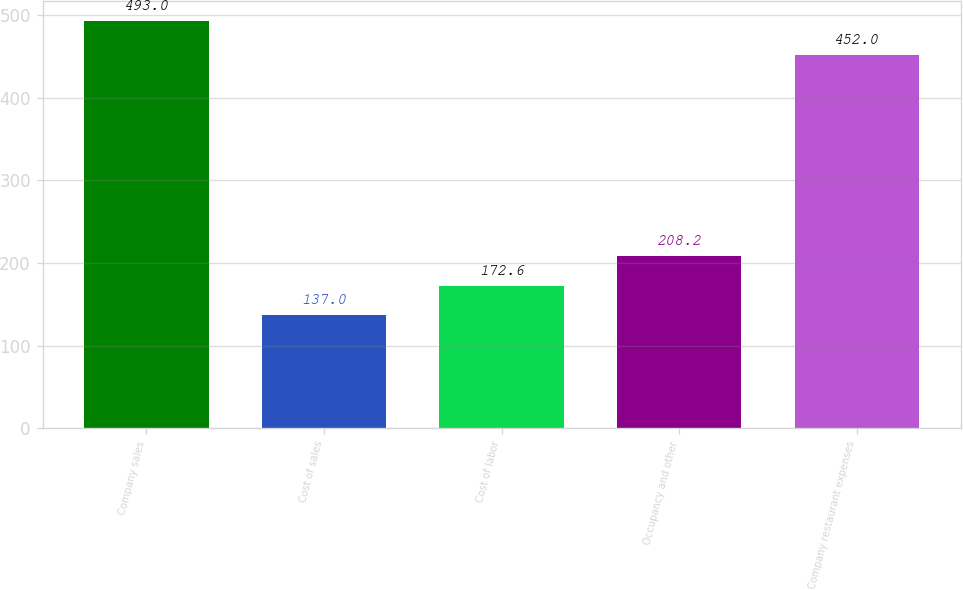Convert chart to OTSL. <chart><loc_0><loc_0><loc_500><loc_500><bar_chart><fcel>Company sales<fcel>Cost of sales<fcel>Cost of labor<fcel>Occupancy and other<fcel>Company restaurant expenses<nl><fcel>493<fcel>137<fcel>172.6<fcel>208.2<fcel>452<nl></chart> 